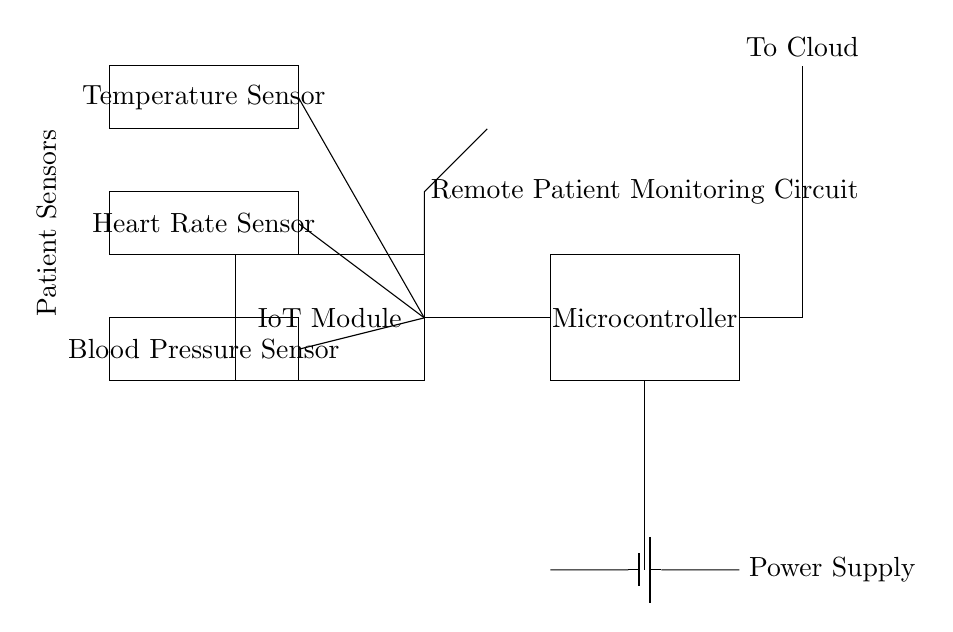What is the purpose of the IoT module? The IoT module enables wireless communication of data collected from the sensors to cloud services for remote monitoring and analysis.
Answer: Wireless communication What type of sensors are included in this circuit? The circuit includes three types of sensors: a temperature sensor, a heart rate sensor, and a blood pressure sensor, as indicated in the diagram.
Answer: Temperature, heart rate, blood pressure Where does the power supply connect to the circuit? The power supply connects to the microcontroller, providing the necessary voltage and current for the operation of the circuit components.
Answer: To the microcontroller How many sensors are connected to the IoT module? Three sensors are connected to the IoT module, as shown by the lines linking the sensors to the IoT module within the circuit diagram.
Answer: Three What is the function of the antenna in this circuit? The antenna facilitates the wireless transmission of data from the IoT module to cloud platforms, enabling remote patient monitoring capabilities.
Answer: Wireless transmission What is the output from the microcontroller? The output from the microcontroller, as noted in the diagram, is directed to the cloud, indicating that patient data is sent for remote monitoring.
Answer: To Cloud What connects the sensors to the IoT module? Wires connect the sensors to the IoT module, allowing electrical signals generated by the sensors to be transmitted to the IoT module for processing.
Answer: Wires 